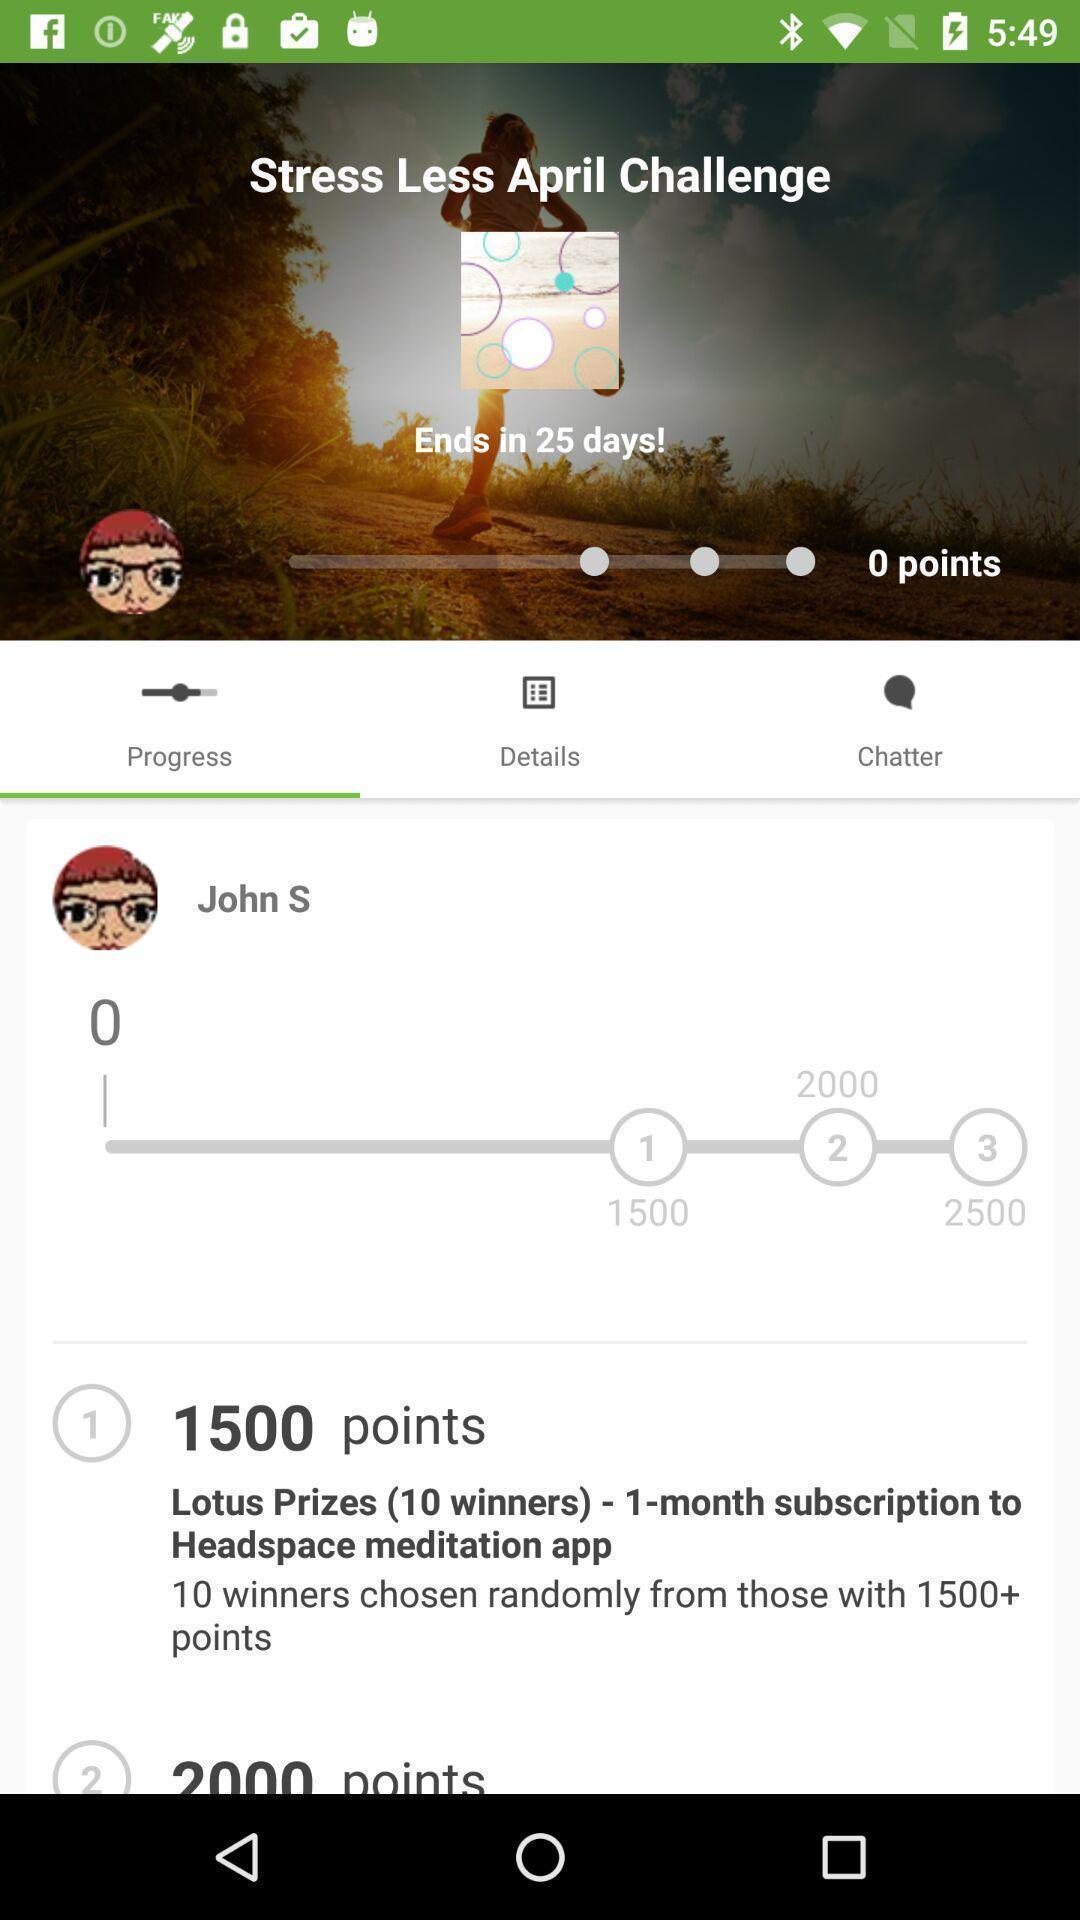Please provide a description for this image. Page showing the options for fitness app. 